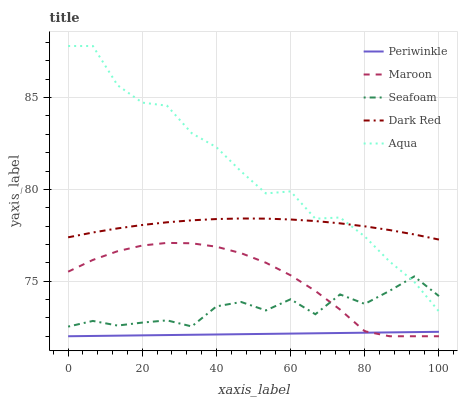Does Periwinkle have the minimum area under the curve?
Answer yes or no. Yes. Does Aqua have the maximum area under the curve?
Answer yes or no. Yes. Does Dark Red have the minimum area under the curve?
Answer yes or no. No. Does Dark Red have the maximum area under the curve?
Answer yes or no. No. Is Periwinkle the smoothest?
Answer yes or no. Yes. Is Seafoam the roughest?
Answer yes or no. Yes. Is Dark Red the smoothest?
Answer yes or no. No. Is Dark Red the roughest?
Answer yes or no. No. Does Periwinkle have the lowest value?
Answer yes or no. Yes. Does Dark Red have the lowest value?
Answer yes or no. No. Does Aqua have the highest value?
Answer yes or no. Yes. Does Dark Red have the highest value?
Answer yes or no. No. Is Maroon less than Dark Red?
Answer yes or no. Yes. Is Dark Red greater than Maroon?
Answer yes or no. Yes. Does Periwinkle intersect Maroon?
Answer yes or no. Yes. Is Periwinkle less than Maroon?
Answer yes or no. No. Is Periwinkle greater than Maroon?
Answer yes or no. No. Does Maroon intersect Dark Red?
Answer yes or no. No. 